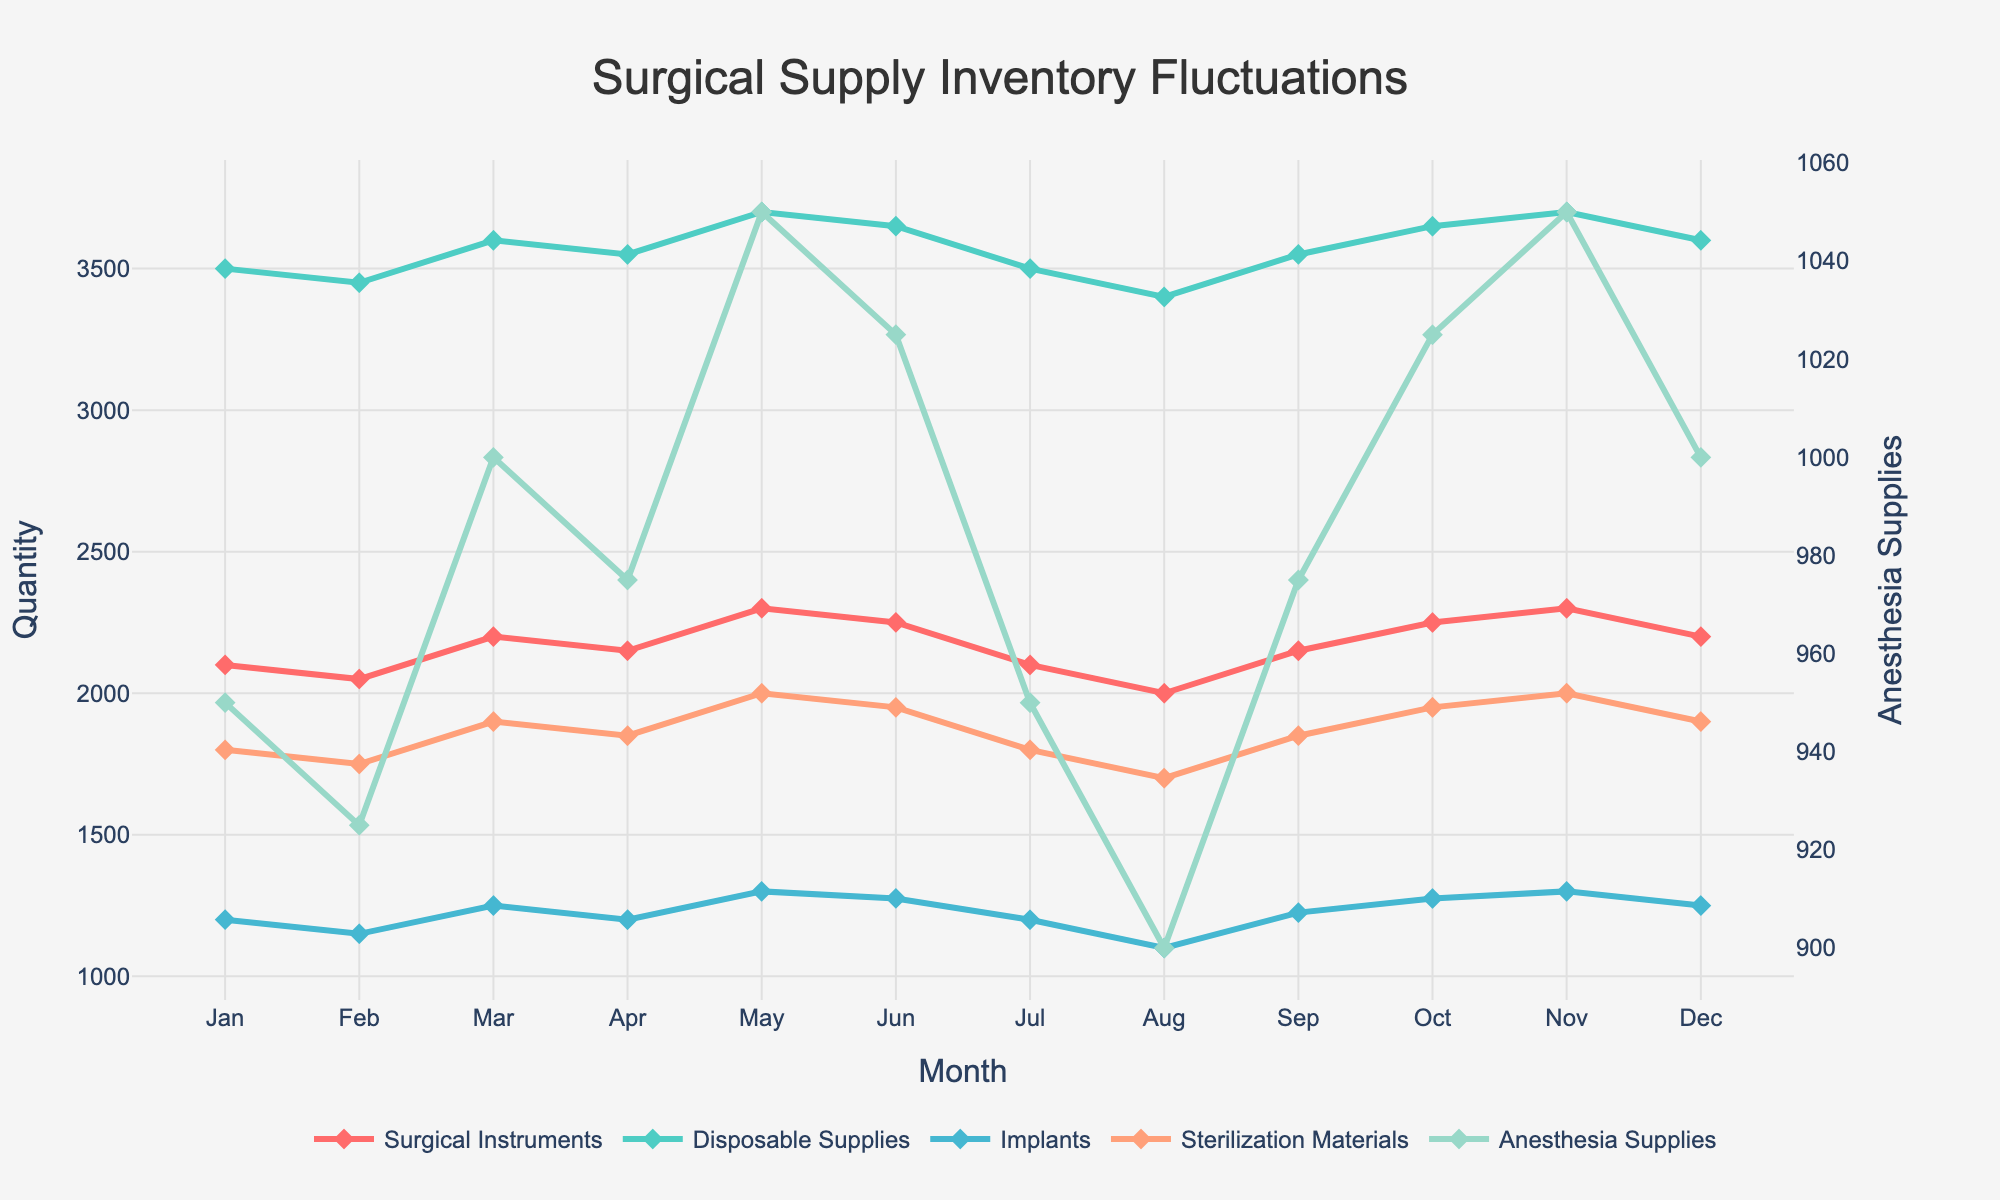compare: How much did the inventory level of Surgical Instruments increase from February to May? To determine this, look at the data points for Surgical Instruments in February (2050) and May (2300). Subtract February's value from May's value: 2300 - 2050 = 250.
Answer: 250 compare: Which month had the highest inventory level for Disposable Supplies? Refer to the data points for Disposable Supplies for every month and identify the highest value which is 3700, occurring in May and November.
Answer: May and November visual: Which category exhibited the lowest fluctuation in its inventory levels throughout the year? Observe the various line charts for each category. The line for Sterilization Materials appears to have the smallest range of fluctuation, remaining relatively stable between 1700 and 2000.
Answer: Sterilization Materials compare: What was the combined inventory level of Surgical Instruments and Anesthesia Supplies in March? Add the values of Surgical Instruments (2200) and Anesthesia Supplies (1000) in March: 2200 + 1000 = 3200.
Answer: 3200 compositional: What is the average inventory level for Implants over the year? Sum the inventory levels of Implants across all months and divide by 12. Sum = 1200 + 1150 + 1250 + 1200 + 1300 + 1275 + 1200 + 1100 + 1225 + 1275 + 1300 + 1250 = 14825. Average = 14825 / 12 = 1235.42 (approximately).
Answer: 1235.42 visual: In which month did the inventory level of Sterilization Materials peak? Check the Sterilization Materials line for the highest peak, which is in May (2000).
Answer: May 